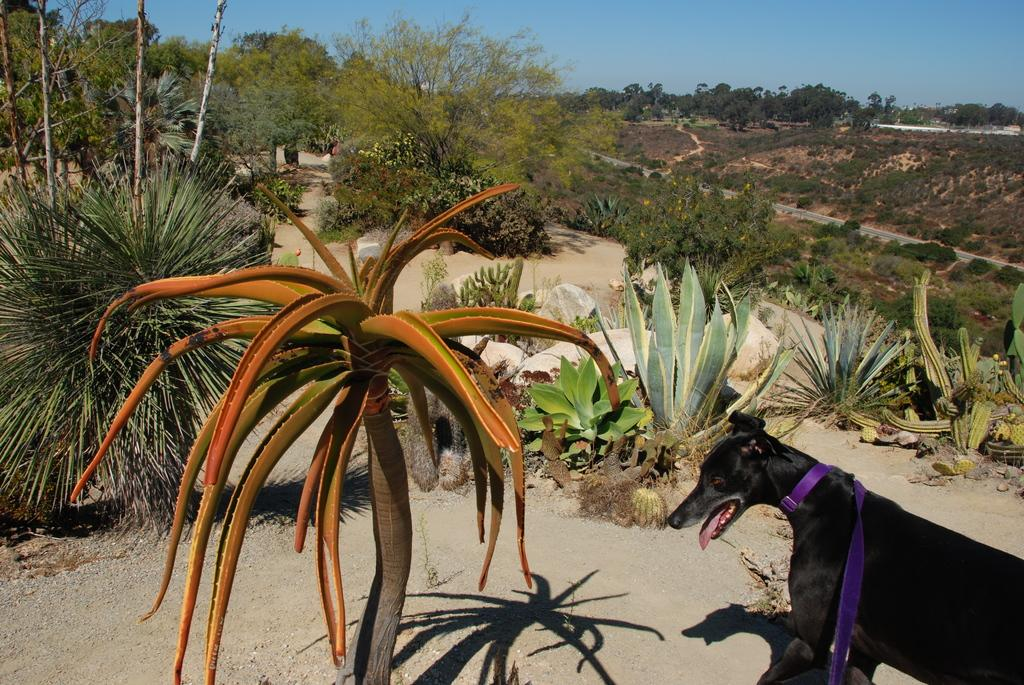What animal can be seen in the image? There is a dog standing on the ground in the image. What type of natural elements are present in the image? There are trees, plants, and stones in the image. What man-made structure can be seen in the image? There is a road in the image. What part of the natural environment is visible in the image? The sky is visible in the image. What type of pan is being used to cook the dog in the image? There is no pan or cooking activity present in the image; it features a dog standing on the ground. What trick is the dog performing in the image? There is no trick being performed by the dog in the image; it is simply standing on the ground. 